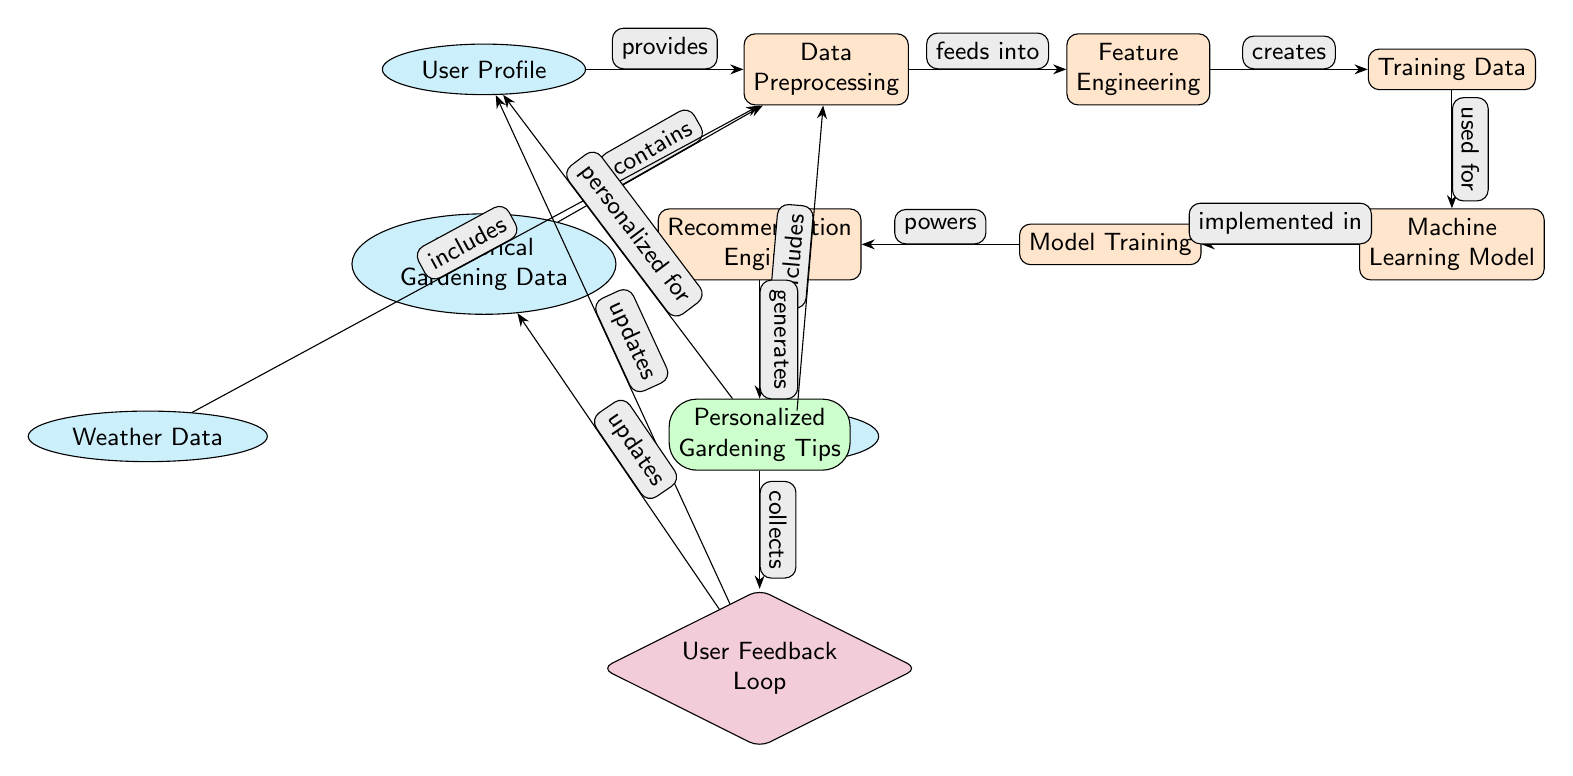What are the initial data sources in this diagram? The initial data sources include the User Profile, Historical Gardening Data, Weather Data, and Soil Data, as indicated by the top nodes in the diagram.
Answer: User Profile, Historical Gardening Data, Weather Data, Soil Data How many main processes are depicted in the diagram? The diagram shows five main processes that transform the data, which are Data Preprocessing, Feature Engineering, Training Data, Machine Learning Model, and Recommendation Engine.
Answer: Five What does the Recommendation Engine generate? The Recommendation Engine generates Personalized Gardening Tips, as shown in the output node connected to it.
Answer: Personalized Gardening Tips What feeds into the Feature Engineering process? The data that feeds into Feature Engineering comprises the output generated from Data Preprocessing, showcasing the workflow from one process to another.
Answer: Training Data How does User Feedback Loop impact the User Profile? The User Feedback Loop updates the User Profile, indicating that feedback collected will modify user data to improve future recommendations.
Answer: Updates Which data includes Weather Data? Weather Data is included in the Data Preprocessing step, forming part of the input data that influences the analysis and recommendations.
Answer: Includes What is the final output of the diagram? The final output of the diagram is Personalized Gardening Tips, indicating that the whole process culminates in generating tailored advice for the user.
Answer: Personalized Gardening Tips How does feedback affect the Historical Gardening Data? The feedback collected from the User Feedback Loop also updates the Historical Gardening Data, suggesting an iterative improvement in the recommendation process over time.
Answer: Updates What is the role of the Machine Learning Model in the diagram? The Machine Learning Model's role is to implement the training data to make predictions or generate recommendations based on inputs.
Answer: Implements 